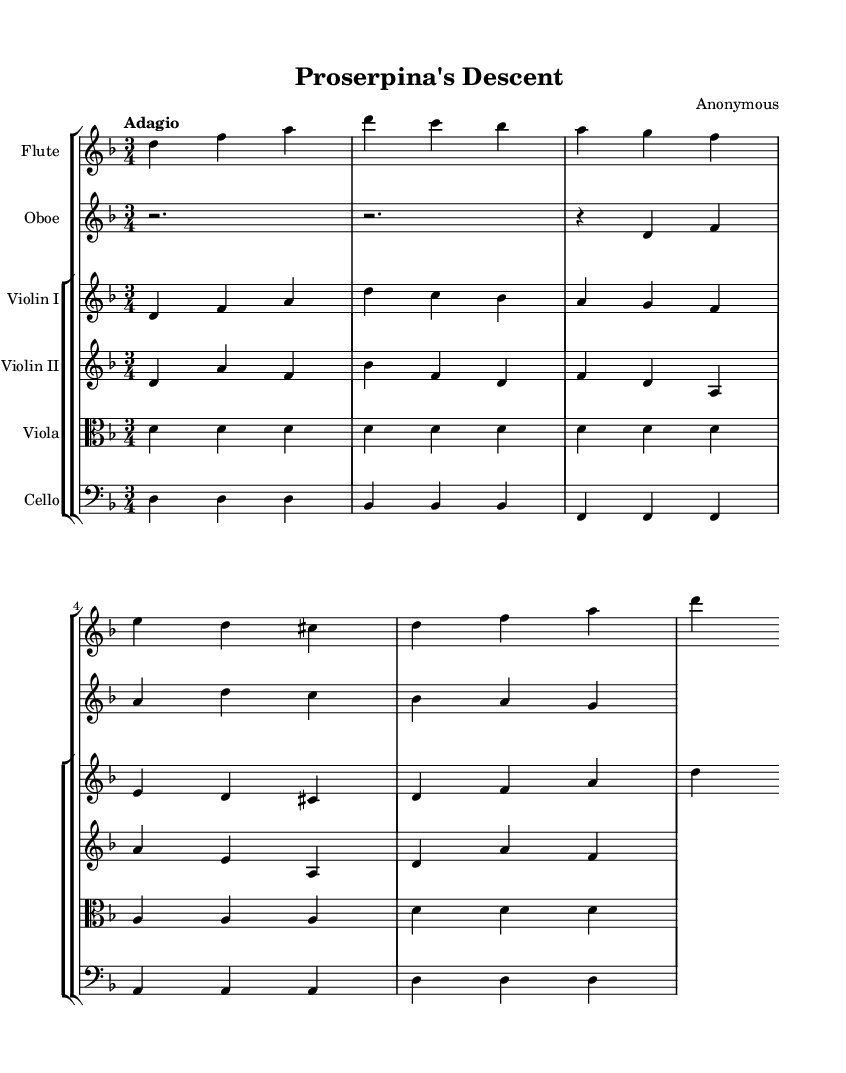What is the key signature of this piece? The key signature has one flat, indicating it is in D minor.
Answer: D minor What is the time signature of the music? The sheet music displays a 3/4 time signature, indicating three beats per measure.
Answer: 3/4 What is the tempo marking used in this composition? The tempo marking indicates "Adagio", which means the piece should be played slowly.
Answer: Adagio How many instruments are featured in this composition? The score lists six unique instruments, which include flute, oboe, two violins, viola, and cello.
Answer: Six Which instrument has the lowest pitch in this ensemble? The cello is written in bass clef, indicating it has the lowest pitch among the instruments.
Answer: Cello Which measure contains the first appearance of a rest? The score shows a rest in the oboe part starting in measure 1, indicating the first silence.
Answer: Measure 1 What is the highest note played in this composition? The highest note appears in the flute part, which is an 'a' note, positioned quite high in the staff.
Answer: A 